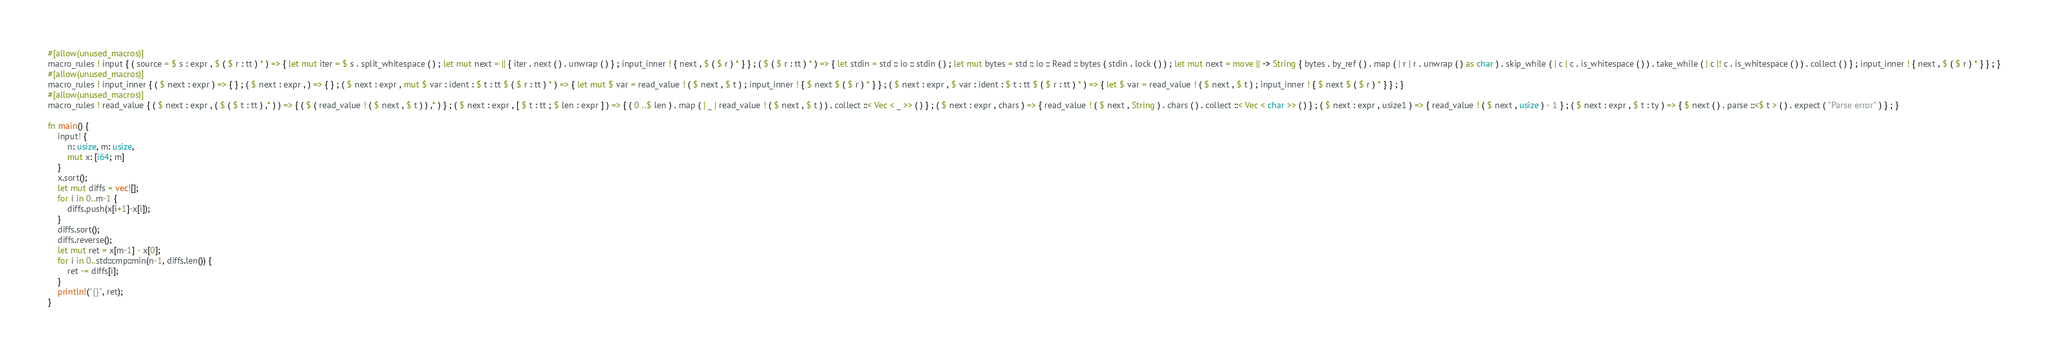<code> <loc_0><loc_0><loc_500><loc_500><_Rust_>#[allow(unused_macros)]
macro_rules ! input { ( source = $ s : expr , $ ( $ r : tt ) * ) => { let mut iter = $ s . split_whitespace ( ) ; let mut next = || { iter . next ( ) . unwrap ( ) } ; input_inner ! { next , $ ( $ r ) * } } ; ( $ ( $ r : tt ) * ) => { let stdin = std :: io :: stdin ( ) ; let mut bytes = std :: io :: Read :: bytes ( stdin . lock ( ) ) ; let mut next = move || -> String { bytes . by_ref ( ) . map ( | r | r . unwrap ( ) as char ) . skip_while ( | c | c . is_whitespace ( ) ) . take_while ( | c |! c . is_whitespace ( ) ) . collect ( ) } ; input_inner ! { next , $ ( $ r ) * } } ; }
#[allow(unused_macros)]
macro_rules ! input_inner { ( $ next : expr ) => { } ; ( $ next : expr , ) => { } ; ( $ next : expr , mut $ var : ident : $ t : tt $ ( $ r : tt ) * ) => { let mut $ var = read_value ! ( $ next , $ t ) ; input_inner ! { $ next $ ( $ r ) * } } ; ( $ next : expr , $ var : ident : $ t : tt $ ( $ r : tt ) * ) => { let $ var = read_value ! ( $ next , $ t ) ; input_inner ! { $ next $ ( $ r ) * } } ; }
#[allow(unused_macros)]
macro_rules ! read_value { ( $ next : expr , ( $ ( $ t : tt ) ,* ) ) => { ( $ ( read_value ! ( $ next , $ t ) ) ,* ) } ; ( $ next : expr , [ $ t : tt ; $ len : expr ] ) => { ( 0 ..$ len ) . map ( | _ | read_value ! ( $ next , $ t ) ) . collect ::< Vec < _ >> ( ) } ; ( $ next : expr , chars ) => { read_value ! ( $ next , String ) . chars ( ) . collect ::< Vec < char >> ( ) } ; ( $ next : expr , usize1 ) => { read_value ! ( $ next , usize ) - 1 } ; ( $ next : expr , $ t : ty ) => { $ next ( ) . parse ::<$ t > ( ) . expect ( "Parse error" ) } ; }

fn main() {
    input! {
        n: usize, m: usize,
        mut x: [i64; m]
    }
    x.sort();
    let mut diffs = vec![];
    for i in 0..m-1 {
        diffs.push(x[i+1]-x[i]);
    }
    diffs.sort();
    diffs.reverse();
    let mut ret = x[m-1] - x[0];
    for i in 0..std::cmp::min(n-1, diffs.len()) {
        ret -= diffs[i];
    }
    println!("{}", ret);
}</code> 